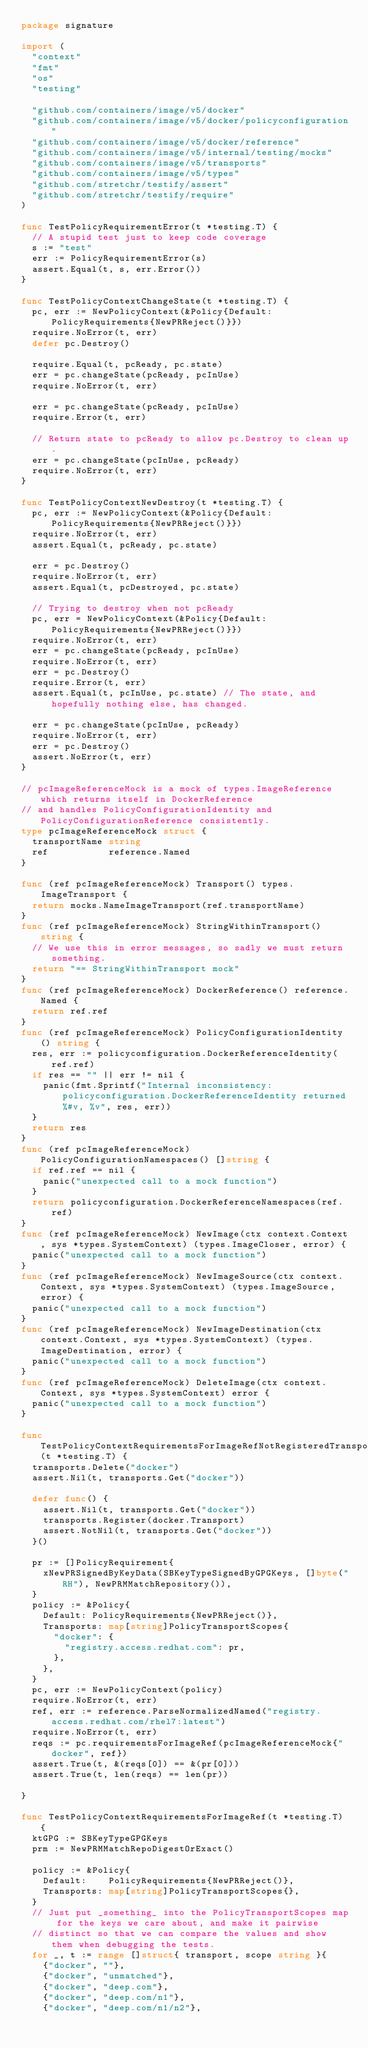<code> <loc_0><loc_0><loc_500><loc_500><_Go_>package signature

import (
	"context"
	"fmt"
	"os"
	"testing"

	"github.com/containers/image/v5/docker"
	"github.com/containers/image/v5/docker/policyconfiguration"
	"github.com/containers/image/v5/docker/reference"
	"github.com/containers/image/v5/internal/testing/mocks"
	"github.com/containers/image/v5/transports"
	"github.com/containers/image/v5/types"
	"github.com/stretchr/testify/assert"
	"github.com/stretchr/testify/require"
)

func TestPolicyRequirementError(t *testing.T) {
	// A stupid test just to keep code coverage
	s := "test"
	err := PolicyRequirementError(s)
	assert.Equal(t, s, err.Error())
}

func TestPolicyContextChangeState(t *testing.T) {
	pc, err := NewPolicyContext(&Policy{Default: PolicyRequirements{NewPRReject()}})
	require.NoError(t, err)
	defer pc.Destroy()

	require.Equal(t, pcReady, pc.state)
	err = pc.changeState(pcReady, pcInUse)
	require.NoError(t, err)

	err = pc.changeState(pcReady, pcInUse)
	require.Error(t, err)

	// Return state to pcReady to allow pc.Destroy to clean up.
	err = pc.changeState(pcInUse, pcReady)
	require.NoError(t, err)
}

func TestPolicyContextNewDestroy(t *testing.T) {
	pc, err := NewPolicyContext(&Policy{Default: PolicyRequirements{NewPRReject()}})
	require.NoError(t, err)
	assert.Equal(t, pcReady, pc.state)

	err = pc.Destroy()
	require.NoError(t, err)
	assert.Equal(t, pcDestroyed, pc.state)

	// Trying to destroy when not pcReady
	pc, err = NewPolicyContext(&Policy{Default: PolicyRequirements{NewPRReject()}})
	require.NoError(t, err)
	err = pc.changeState(pcReady, pcInUse)
	require.NoError(t, err)
	err = pc.Destroy()
	require.Error(t, err)
	assert.Equal(t, pcInUse, pc.state) // The state, and hopefully nothing else, has changed.

	err = pc.changeState(pcInUse, pcReady)
	require.NoError(t, err)
	err = pc.Destroy()
	assert.NoError(t, err)
}

// pcImageReferenceMock is a mock of types.ImageReference which returns itself in DockerReference
// and handles PolicyConfigurationIdentity and PolicyConfigurationReference consistently.
type pcImageReferenceMock struct {
	transportName string
	ref           reference.Named
}

func (ref pcImageReferenceMock) Transport() types.ImageTransport {
	return mocks.NameImageTransport(ref.transportName)
}
func (ref pcImageReferenceMock) StringWithinTransport() string {
	// We use this in error messages, so sadly we must return something.
	return "== StringWithinTransport mock"
}
func (ref pcImageReferenceMock) DockerReference() reference.Named {
	return ref.ref
}
func (ref pcImageReferenceMock) PolicyConfigurationIdentity() string {
	res, err := policyconfiguration.DockerReferenceIdentity(ref.ref)
	if res == "" || err != nil {
		panic(fmt.Sprintf("Internal inconsistency: policyconfiguration.DockerReferenceIdentity returned %#v, %v", res, err))
	}
	return res
}
func (ref pcImageReferenceMock) PolicyConfigurationNamespaces() []string {
	if ref.ref == nil {
		panic("unexpected call to a mock function")
	}
	return policyconfiguration.DockerReferenceNamespaces(ref.ref)
}
func (ref pcImageReferenceMock) NewImage(ctx context.Context, sys *types.SystemContext) (types.ImageCloser, error) {
	panic("unexpected call to a mock function")
}
func (ref pcImageReferenceMock) NewImageSource(ctx context.Context, sys *types.SystemContext) (types.ImageSource, error) {
	panic("unexpected call to a mock function")
}
func (ref pcImageReferenceMock) NewImageDestination(ctx context.Context, sys *types.SystemContext) (types.ImageDestination, error) {
	panic("unexpected call to a mock function")
}
func (ref pcImageReferenceMock) DeleteImage(ctx context.Context, sys *types.SystemContext) error {
	panic("unexpected call to a mock function")
}

func TestPolicyContextRequirementsForImageRefNotRegisteredTransport(t *testing.T) {
	transports.Delete("docker")
	assert.Nil(t, transports.Get("docker"))

	defer func() {
		assert.Nil(t, transports.Get("docker"))
		transports.Register(docker.Transport)
		assert.NotNil(t, transports.Get("docker"))
	}()

	pr := []PolicyRequirement{
		xNewPRSignedByKeyData(SBKeyTypeSignedByGPGKeys, []byte("RH"), NewPRMMatchRepository()),
	}
	policy := &Policy{
		Default: PolicyRequirements{NewPRReject()},
		Transports: map[string]PolicyTransportScopes{
			"docker": {
				"registry.access.redhat.com": pr,
			},
		},
	}
	pc, err := NewPolicyContext(policy)
	require.NoError(t, err)
	ref, err := reference.ParseNormalizedNamed("registry.access.redhat.com/rhel7:latest")
	require.NoError(t, err)
	reqs := pc.requirementsForImageRef(pcImageReferenceMock{"docker", ref})
	assert.True(t, &(reqs[0]) == &(pr[0]))
	assert.True(t, len(reqs) == len(pr))

}

func TestPolicyContextRequirementsForImageRef(t *testing.T) {
	ktGPG := SBKeyTypeGPGKeys
	prm := NewPRMMatchRepoDigestOrExact()

	policy := &Policy{
		Default:    PolicyRequirements{NewPRReject()},
		Transports: map[string]PolicyTransportScopes{},
	}
	// Just put _something_ into the PolicyTransportScopes map for the keys we care about, and make it pairwise
	// distinct so that we can compare the values and show them when debugging the tests.
	for _, t := range []struct{ transport, scope string }{
		{"docker", ""},
		{"docker", "unmatched"},
		{"docker", "deep.com"},
		{"docker", "deep.com/n1"},
		{"docker", "deep.com/n1/n2"},</code> 